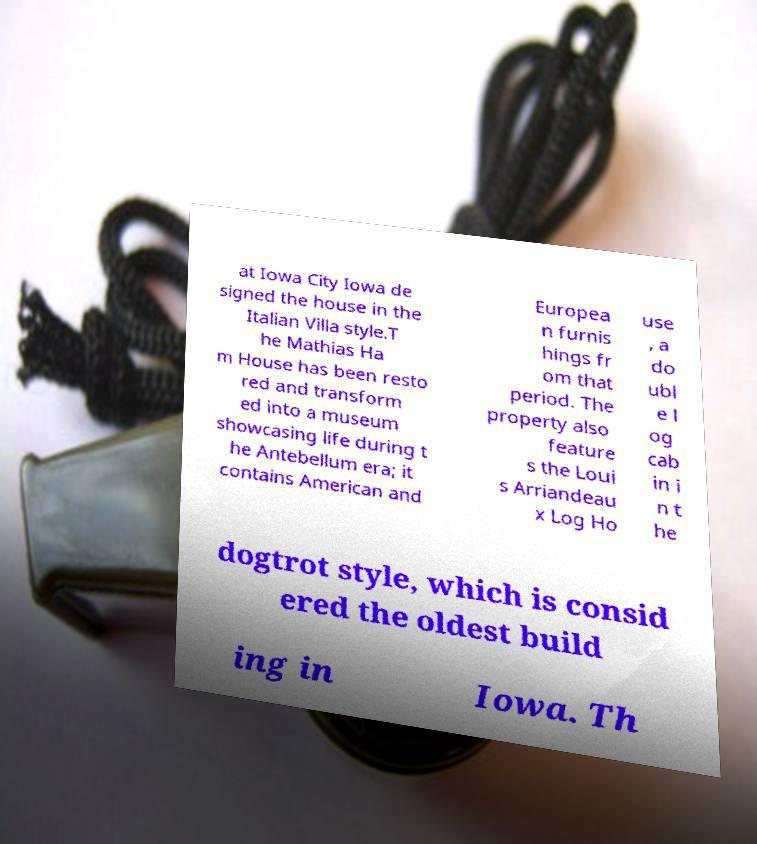For documentation purposes, I need the text within this image transcribed. Could you provide that? at Iowa City Iowa de signed the house in the Italian Villa style.T he Mathias Ha m House has been resto red and transform ed into a museum showcasing life during t he Antebellum era; it contains American and Europea n furnis hings fr om that period. The property also feature s the Loui s Arriandeau x Log Ho use , a do ubl e l og cab in i n t he dogtrot style, which is consid ered the oldest build ing in Iowa. Th 